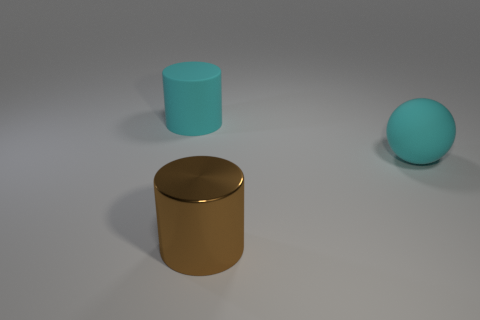Add 3 cyan cylinders. How many objects exist? 6 Subtract all cylinders. How many objects are left? 1 Subtract all large brown cylinders. Subtract all rubber spheres. How many objects are left? 1 Add 2 balls. How many balls are left? 3 Add 1 gray metal balls. How many gray metal balls exist? 1 Subtract 0 brown blocks. How many objects are left? 3 